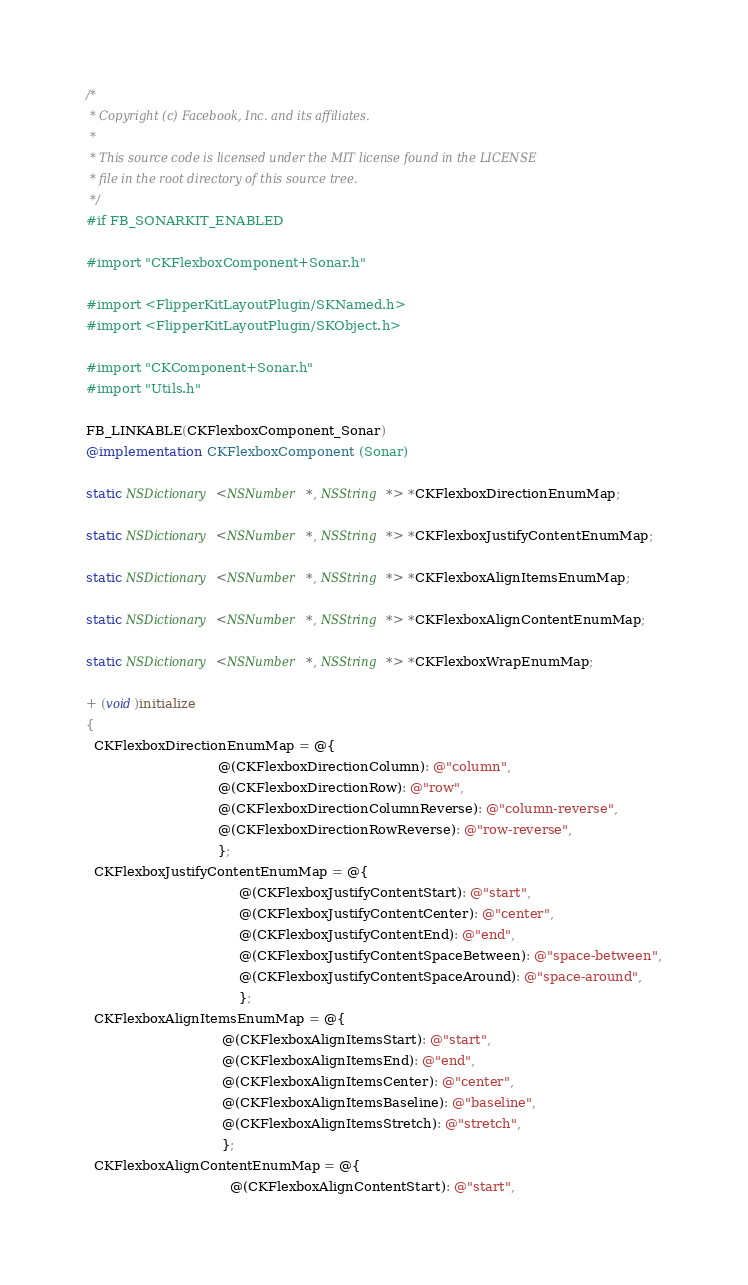Convert code to text. <code><loc_0><loc_0><loc_500><loc_500><_ObjectiveC_>/*
 * Copyright (c) Facebook, Inc. and its affiliates.
 *
 * This source code is licensed under the MIT license found in the LICENSE
 * file in the root directory of this source tree.
 */
#if FB_SONARKIT_ENABLED

#import "CKFlexboxComponent+Sonar.h"

#import <FlipperKitLayoutPlugin/SKNamed.h>
#import <FlipperKitLayoutPlugin/SKObject.h>

#import "CKComponent+Sonar.h"
#import "Utils.h"

FB_LINKABLE(CKFlexboxComponent_Sonar)
@implementation CKFlexboxComponent (Sonar)

static NSDictionary<NSNumber *, NSString *> *CKFlexboxDirectionEnumMap;

static NSDictionary<NSNumber *, NSString *> *CKFlexboxJustifyContentEnumMap;

static NSDictionary<NSNumber *, NSString *> *CKFlexboxAlignItemsEnumMap;

static NSDictionary<NSNumber *, NSString *> *CKFlexboxAlignContentEnumMap;

static NSDictionary<NSNumber *, NSString *> *CKFlexboxWrapEnumMap;

+ (void)initialize
{
  CKFlexboxDirectionEnumMap = @{
                                @(CKFlexboxDirectionColumn): @"column",
                                @(CKFlexboxDirectionRow): @"row",
                                @(CKFlexboxDirectionColumnReverse): @"column-reverse",
                                @(CKFlexboxDirectionRowReverse): @"row-reverse",
                                };
  CKFlexboxJustifyContentEnumMap = @{
                                     @(CKFlexboxJustifyContentStart): @"start",
                                     @(CKFlexboxJustifyContentCenter): @"center",
                                     @(CKFlexboxJustifyContentEnd): @"end",
                                     @(CKFlexboxJustifyContentSpaceBetween): @"space-between",
                                     @(CKFlexboxJustifyContentSpaceAround): @"space-around",
                                     };
  CKFlexboxAlignItemsEnumMap = @{
                                 @(CKFlexboxAlignItemsStart): @"start",
                                 @(CKFlexboxAlignItemsEnd): @"end",
                                 @(CKFlexboxAlignItemsCenter): @"center",
                                 @(CKFlexboxAlignItemsBaseline): @"baseline",
                                 @(CKFlexboxAlignItemsStretch): @"stretch",
                                 };
  CKFlexboxAlignContentEnumMap = @{
                                   @(CKFlexboxAlignContentStart): @"start",</code> 